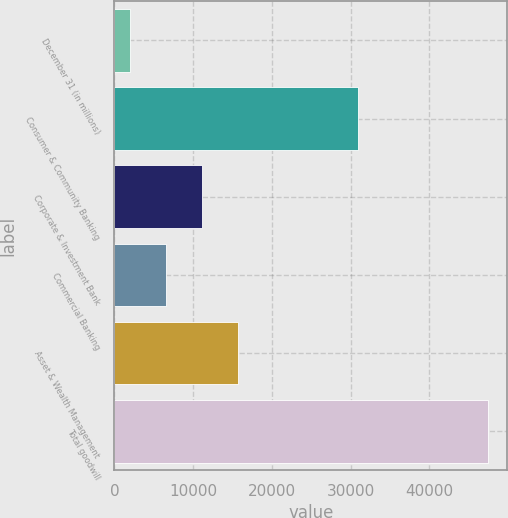<chart> <loc_0><loc_0><loc_500><loc_500><bar_chart><fcel>December 31 (in millions)<fcel>Consumer & Community Banking<fcel>Corporate & Investment Bank<fcel>Commercial Banking<fcel>Asset & Wealth Management<fcel>Total goodwill<nl><fcel>2018<fcel>30984<fcel>11108.6<fcel>6563.3<fcel>15653.9<fcel>47471<nl></chart> 